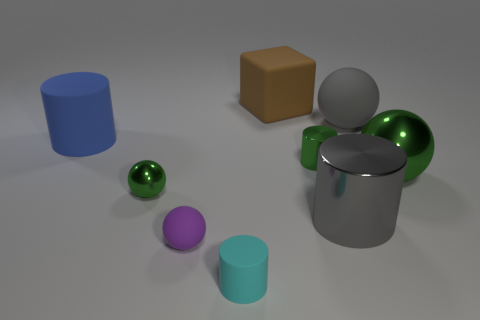Are there the same number of cyan things that are behind the purple rubber object and tiny green things?
Make the answer very short. No. There is a green thing left of the rubber ball on the left side of the tiny green metal cylinder; what number of brown objects are in front of it?
Provide a short and direct response. 0. There is a cyan matte cylinder; is it the same size as the matte ball that is to the left of the large block?
Offer a very short reply. Yes. How many tiny cylinders are there?
Make the answer very short. 2. There is a matte cylinder in front of the blue cylinder; is it the same size as the ball that is in front of the large gray cylinder?
Give a very brief answer. Yes. The tiny metal thing that is the same shape as the large green thing is what color?
Your response must be concise. Green. Does the big blue object have the same shape as the gray metallic thing?
Keep it short and to the point. Yes. What size is the gray metallic thing that is the same shape as the tiny cyan matte thing?
Your response must be concise. Large. How many large gray objects have the same material as the blue cylinder?
Give a very brief answer. 1. What number of things are either large purple balls or small cyan cylinders?
Make the answer very short. 1. 